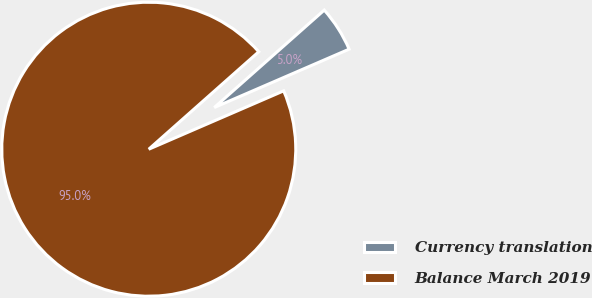<chart> <loc_0><loc_0><loc_500><loc_500><pie_chart><fcel>Currency translation<fcel>Balance March 2019<nl><fcel>5.04%<fcel>94.96%<nl></chart> 